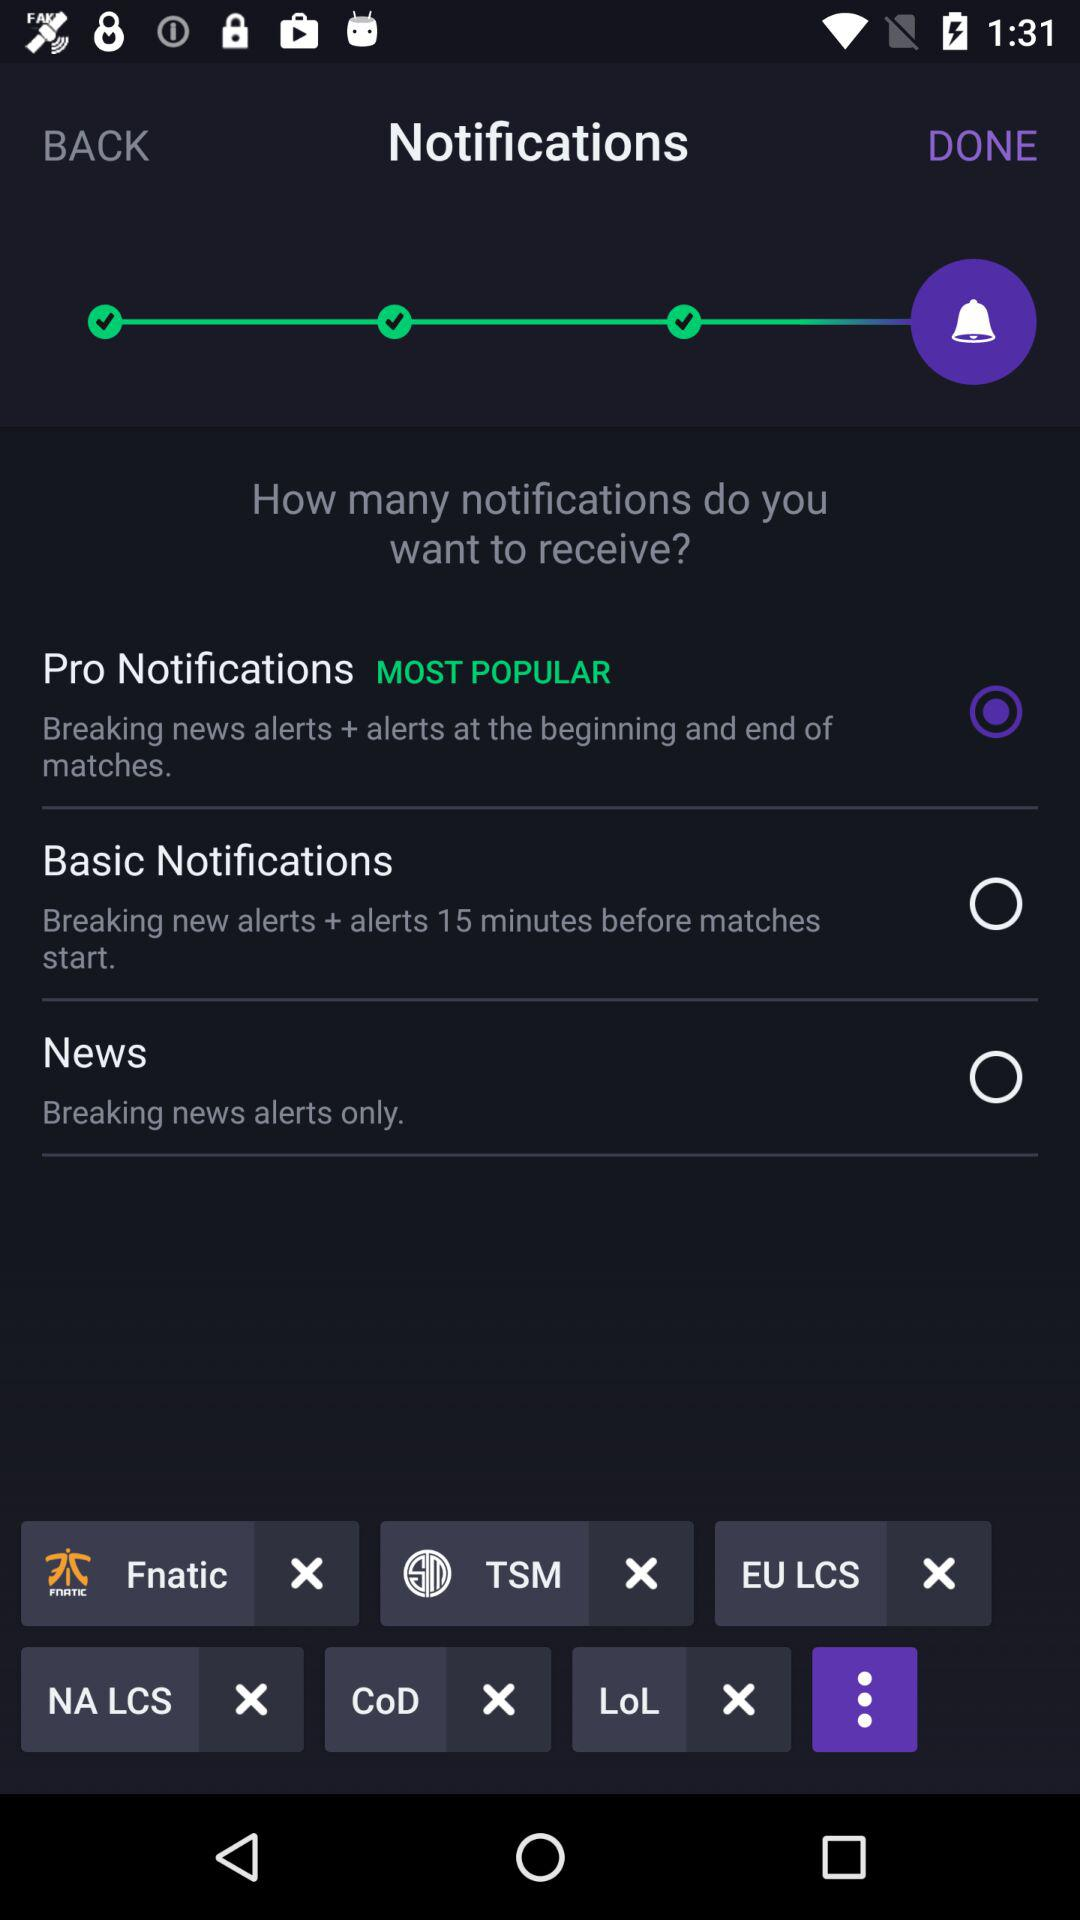What is the notification status of news? The status is off. 